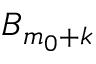Convert formula to latex. <formula><loc_0><loc_0><loc_500><loc_500>B _ { m _ { 0 } + k }</formula> 